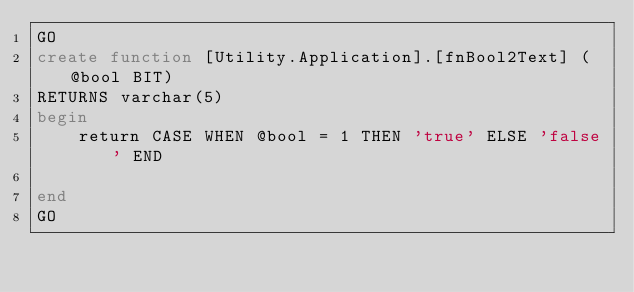Convert code to text. <code><loc_0><loc_0><loc_500><loc_500><_SQL_>GO
create function [Utility.Application].[fnBool2Text] (@bool BIT)
RETURNS varchar(5) 
begin
	return CASE WHEN @bool = 1 THEN 'true' ELSE 'false' END
	
end
GO
</code> 